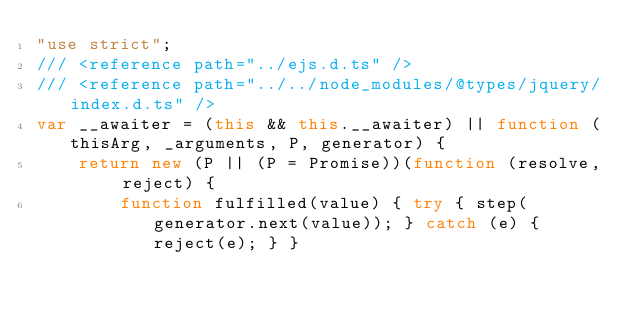<code> <loc_0><loc_0><loc_500><loc_500><_JavaScript_>"use strict";
/// <reference path="../ejs.d.ts" />
/// <reference path="../../node_modules/@types/jquery/index.d.ts" />
var __awaiter = (this && this.__awaiter) || function (thisArg, _arguments, P, generator) {
    return new (P || (P = Promise))(function (resolve, reject) {
        function fulfilled(value) { try { step(generator.next(value)); } catch (e) { reject(e); } }</code> 